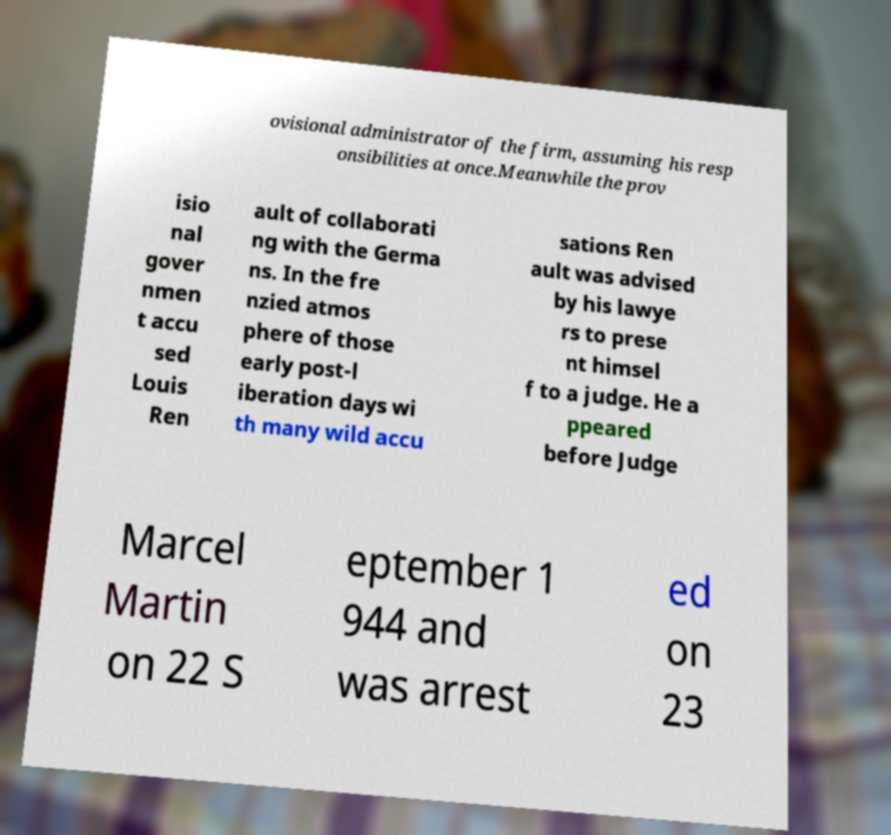Can you read and provide the text displayed in the image?This photo seems to have some interesting text. Can you extract and type it out for me? ovisional administrator of the firm, assuming his resp onsibilities at once.Meanwhile the prov isio nal gover nmen t accu sed Louis Ren ault of collaborati ng with the Germa ns. In the fre nzied atmos phere of those early post-l iberation days wi th many wild accu sations Ren ault was advised by his lawye rs to prese nt himsel f to a judge. He a ppeared before Judge Marcel Martin on 22 S eptember 1 944 and was arrest ed on 23 